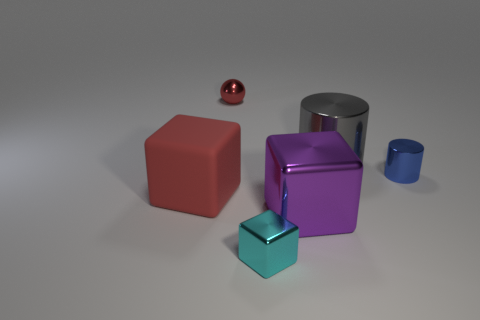Add 4 tiny blue metallic blocks. How many objects exist? 10 Subtract all cylinders. How many objects are left? 4 Add 5 brown rubber cylinders. How many brown rubber cylinders exist? 5 Subtract 0 cyan cylinders. How many objects are left? 6 Subtract all tiny yellow matte cylinders. Subtract all big red matte blocks. How many objects are left? 5 Add 2 blue metallic cylinders. How many blue metallic cylinders are left? 3 